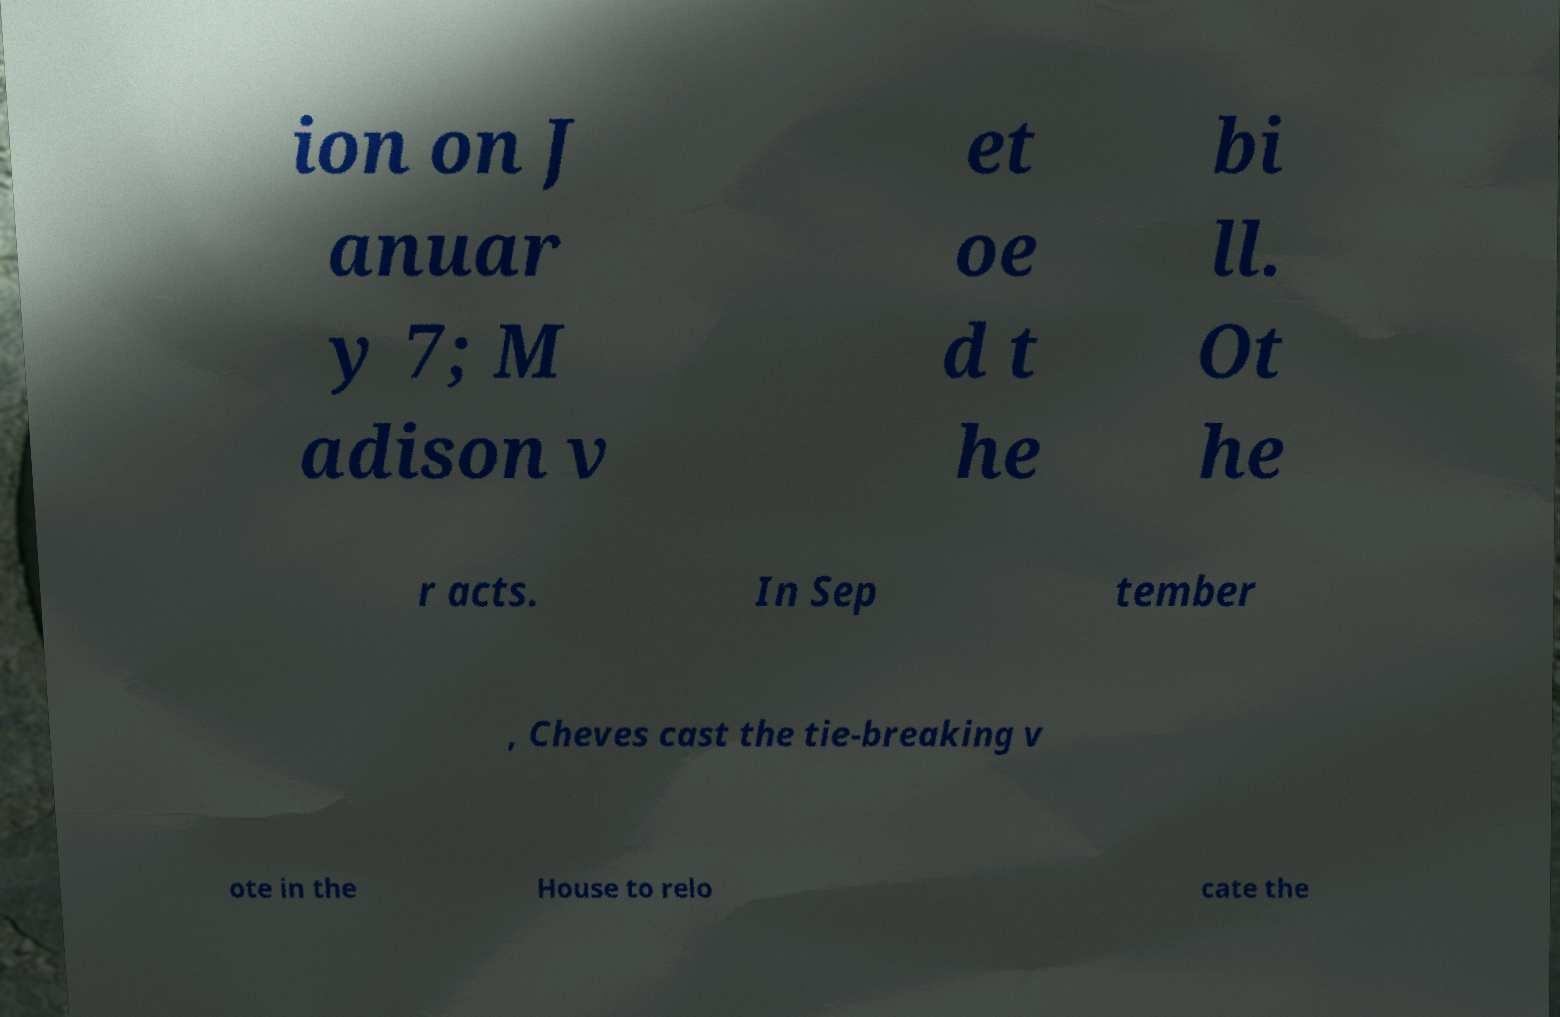There's text embedded in this image that I need extracted. Can you transcribe it verbatim? ion on J anuar y 7; M adison v et oe d t he bi ll. Ot he r acts. In Sep tember , Cheves cast the tie-breaking v ote in the House to relo cate the 